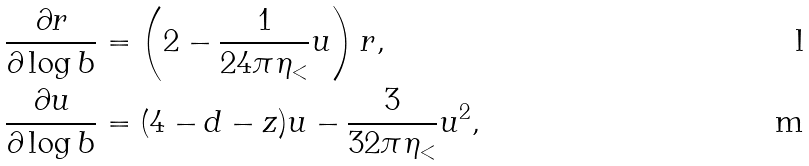<formula> <loc_0><loc_0><loc_500><loc_500>\frac { \partial r } { \partial \log b } & = \left ( 2 - \frac { 1 } { 2 4 \pi \eta _ { < } } u \right ) r , \\ \frac { \partial u } { \partial \log b } & = ( 4 - d - z ) u - \frac { 3 } { 3 2 \pi \eta _ { < } } u ^ { 2 } ,</formula> 